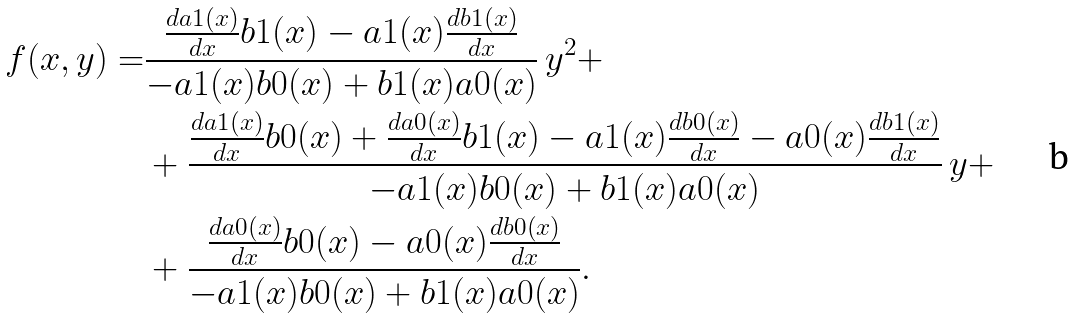Convert formula to latex. <formula><loc_0><loc_0><loc_500><loc_500>f ( x , y ) = & \frac { \frac { d a 1 ( x ) } { d x } b 1 ( x ) - a 1 ( x ) \frac { d b 1 ( x ) } { d x } } { - a 1 ( x ) b 0 ( x ) + b 1 ( x ) a 0 ( x ) } \, y ^ { 2 } + \\ & + \frac { \frac { d a 1 ( x ) } { d x } b 0 ( x ) + \frac { d a 0 ( x ) } { d x } b 1 ( x ) - a 1 ( x ) \frac { d b 0 ( x ) } { d x } - a 0 ( x ) \frac { d b 1 ( x ) } { d x } } { - a 1 ( x ) b 0 ( x ) + b 1 ( x ) a 0 ( x ) } \, y + \\ & + \frac { \frac { d a 0 ( x ) } { d x } b 0 ( x ) - a 0 ( x ) \frac { d b 0 ( x ) } { d x } } { - a 1 ( x ) b 0 ( x ) + b 1 ( x ) a 0 ( x ) } .</formula> 